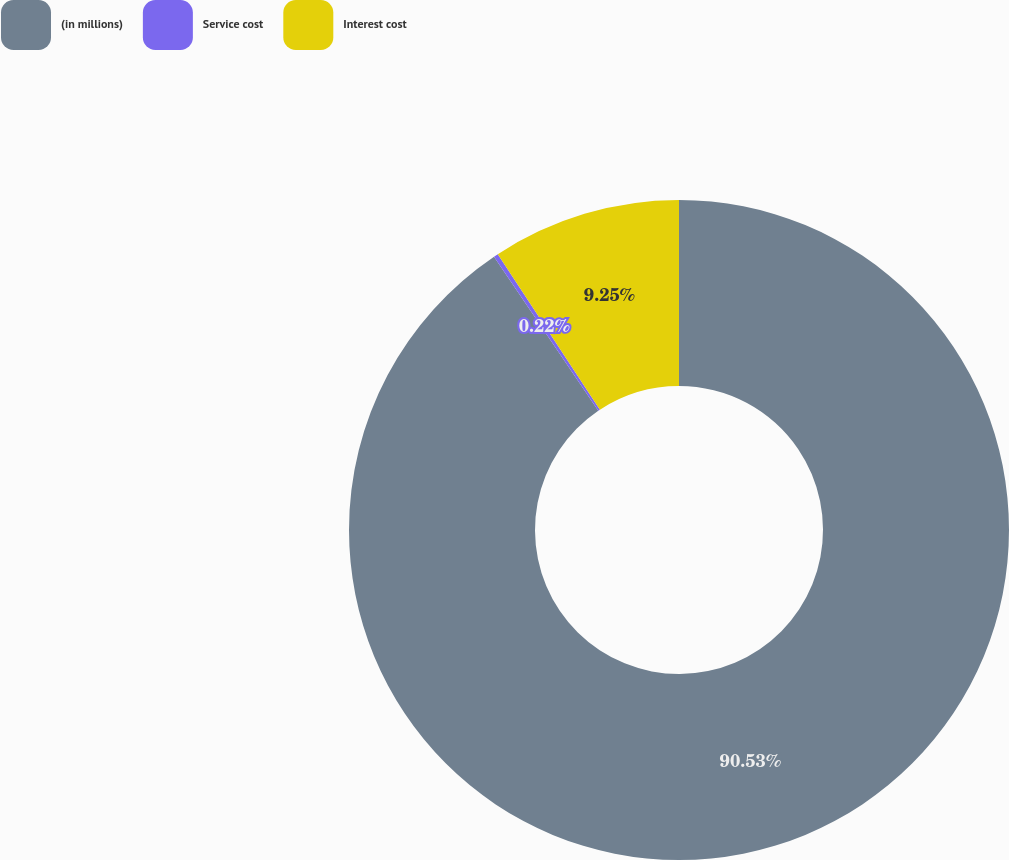Convert chart. <chart><loc_0><loc_0><loc_500><loc_500><pie_chart><fcel>(in millions)<fcel>Service cost<fcel>Interest cost<nl><fcel>90.52%<fcel>0.22%<fcel>9.25%<nl></chart> 